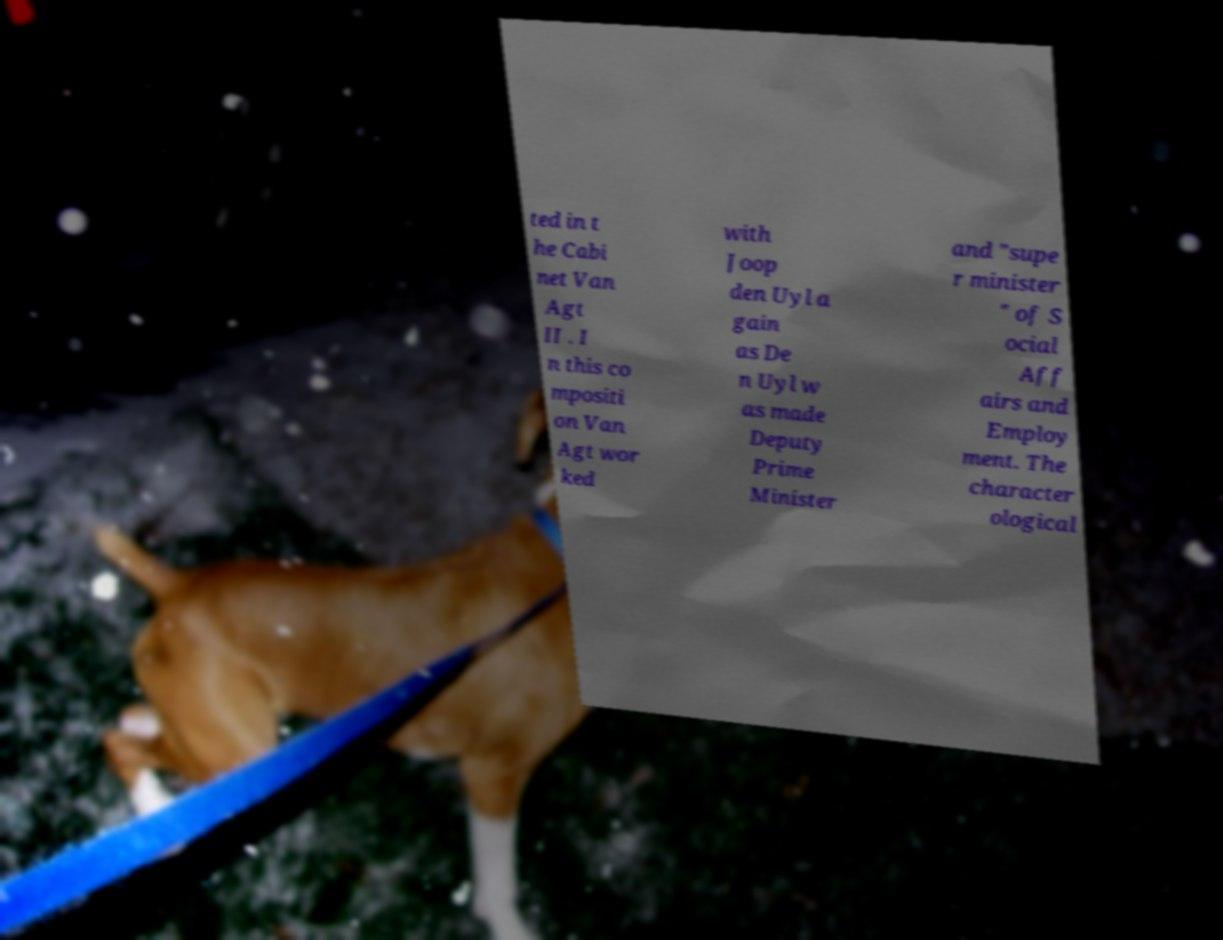Please read and relay the text visible in this image. What does it say? ted in t he Cabi net Van Agt II . I n this co mpositi on Van Agt wor ked with Joop den Uyl a gain as De n Uyl w as made Deputy Prime Minister and "supe r minister " of S ocial Aff airs and Employ ment. The character ological 